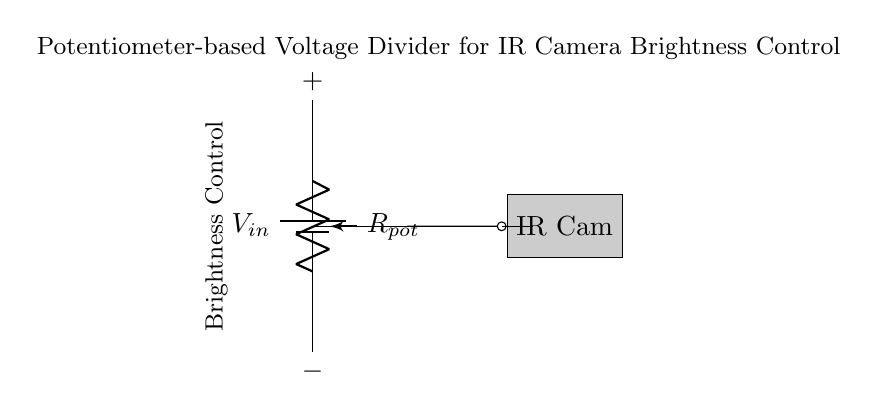What is the input voltage in this circuit? The input voltage refers to the voltage supplied by the battery, represented as \( V_{in} \) in the circuit. The specific value is not provided in the diagram, but it is essential to know that it powers the circuit.
Answer: \( V_{in} \) What type of component is used for brightness control? The component used for brightness control is a potentiometer, labeled as \( R_{pot} \) in the circuit. This component can vary resistance to adjust the output voltage that corresponds to the brightness of the infrared camera.
Answer: Potentiometer What is the output voltage connected to? The output voltage, labeled \( V_{out} \), is connected to an infrared camera denoted as "IR Cam" in the diagram. This indicates that the voltage divider's output is used to control the camera's brightness level.
Answer: IR Cam How do the wires connect the components? The wires connect the battery to the potentiometer and then to the infrared camera, forming a continuous circuit. The top of the potentiometer connects to the positive terminal of the battery, and the output from the potentiometer leads to the infrared camera.
Answer: In series What effect does adjusting the potentiometer have on the output voltage? Adjusting the potentiometer changes its resistance, which alters the voltage drop across it due to the voltage divider principle. As resistance changes, the output voltage (\( V_{out} \)) will either increase or decrease, effectively controlling the brightness of the infrared camera.
Answer: Alters voltage drop What is the role of the ground connection in this circuit? The ground connection in this circuit serves as a reference point for the voltage measurements and completes the circuit. It provides a return path for current, ensuring that the circuit operates correctly by maintaining a defined zero potential for all connected components.
Answer: Reference point 